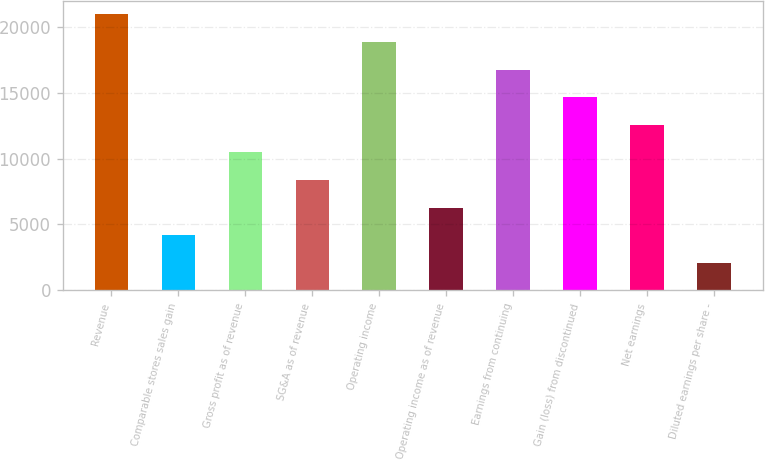Convert chart. <chart><loc_0><loc_0><loc_500><loc_500><bar_chart><fcel>Revenue<fcel>Comparable stores sales gain<fcel>Gross profit as of revenue<fcel>SG&A as of revenue<fcel>Operating income<fcel>Operating income as of revenue<fcel>Earnings from continuing<fcel>Gain (loss) from discontinued<fcel>Net earnings<fcel>Diluted earnings per share -<nl><fcel>20943<fcel>4188.85<fcel>10471.7<fcel>8377.39<fcel>18848.7<fcel>6283.12<fcel>16754.5<fcel>14660.2<fcel>12565.9<fcel>2094.58<nl></chart> 